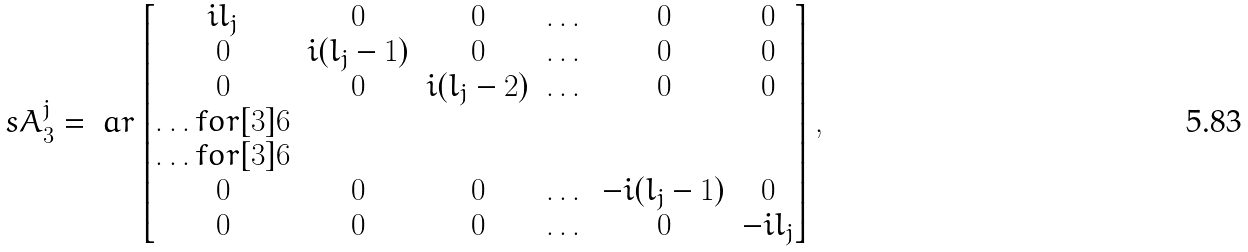<formula> <loc_0><loc_0><loc_500><loc_500>\ s A ^ { j } _ { 3 } = \ a r \begin{bmatrix} i l _ { j } & 0 & 0 & \dots & 0 & 0 \\ 0 & i ( l _ { j } - 1 ) & 0 & \dots & 0 & 0 \\ 0 & 0 & i ( l _ { j } - 2 ) & \dots & 0 & 0 \\ \hdots f o r [ 3 ] { 6 } \\ \hdots f o r [ 3 ] { 6 } \\ 0 & 0 & 0 & \dots & - i ( l _ { j } - 1 ) & 0 \\ 0 & 0 & 0 & \dots & 0 & - i l _ { j } \end{bmatrix} ,</formula> 